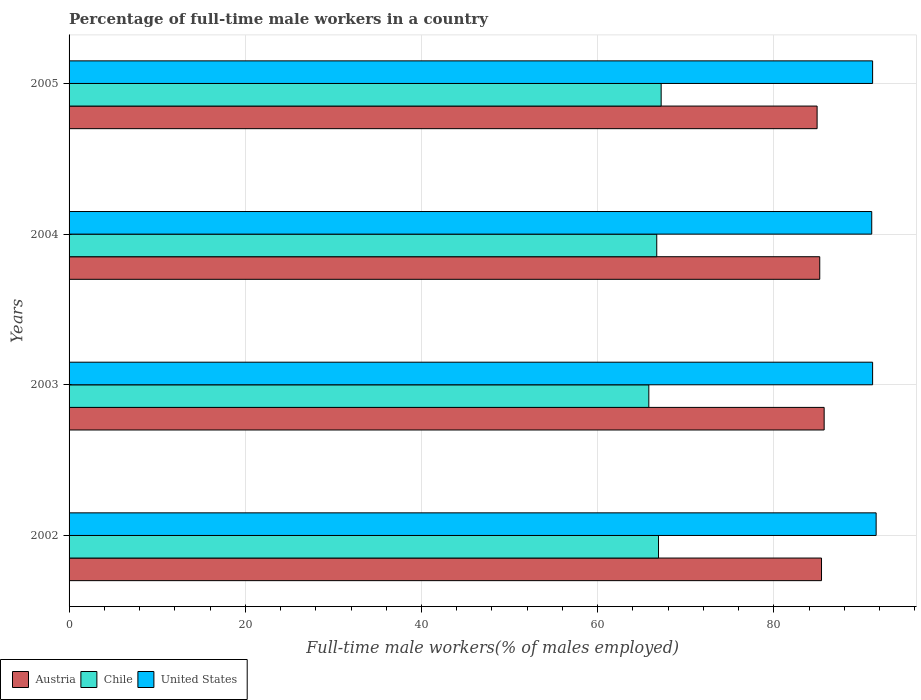How many different coloured bars are there?
Keep it short and to the point. 3. How many groups of bars are there?
Provide a short and direct response. 4. Are the number of bars per tick equal to the number of legend labels?
Give a very brief answer. Yes. How many bars are there on the 1st tick from the top?
Your response must be concise. 3. How many bars are there on the 3rd tick from the bottom?
Provide a short and direct response. 3. In how many cases, is the number of bars for a given year not equal to the number of legend labels?
Offer a terse response. 0. What is the percentage of full-time male workers in Austria in 2003?
Make the answer very short. 85.7. Across all years, what is the maximum percentage of full-time male workers in Austria?
Ensure brevity in your answer.  85.7. Across all years, what is the minimum percentage of full-time male workers in Chile?
Provide a succinct answer. 65.8. In which year was the percentage of full-time male workers in United States maximum?
Your answer should be very brief. 2002. What is the total percentage of full-time male workers in Austria in the graph?
Give a very brief answer. 341.2. What is the difference between the percentage of full-time male workers in Chile in 2002 and that in 2005?
Your response must be concise. -0.3. What is the difference between the percentage of full-time male workers in Austria in 2003 and the percentage of full-time male workers in Chile in 2002?
Offer a terse response. 18.8. What is the average percentage of full-time male workers in Chile per year?
Make the answer very short. 66.65. In the year 2002, what is the difference between the percentage of full-time male workers in United States and percentage of full-time male workers in Austria?
Ensure brevity in your answer.  6.2. What is the ratio of the percentage of full-time male workers in United States in 2004 to that in 2005?
Provide a succinct answer. 1. Is the percentage of full-time male workers in Austria in 2003 less than that in 2004?
Your response must be concise. No. Is the difference between the percentage of full-time male workers in United States in 2002 and 2004 greater than the difference between the percentage of full-time male workers in Austria in 2002 and 2004?
Give a very brief answer. Yes. What is the difference between the highest and the second highest percentage of full-time male workers in Chile?
Provide a succinct answer. 0.3. What is the difference between the highest and the lowest percentage of full-time male workers in Chile?
Give a very brief answer. 1.4. In how many years, is the percentage of full-time male workers in United States greater than the average percentage of full-time male workers in United States taken over all years?
Your answer should be very brief. 1. What does the 3rd bar from the top in 2005 represents?
Ensure brevity in your answer.  Austria. What does the 2nd bar from the bottom in 2003 represents?
Provide a succinct answer. Chile. Is it the case that in every year, the sum of the percentage of full-time male workers in United States and percentage of full-time male workers in Chile is greater than the percentage of full-time male workers in Austria?
Keep it short and to the point. Yes. How many bars are there?
Offer a very short reply. 12. Are the values on the major ticks of X-axis written in scientific E-notation?
Your response must be concise. No. Does the graph contain any zero values?
Offer a very short reply. No. Where does the legend appear in the graph?
Ensure brevity in your answer.  Bottom left. What is the title of the graph?
Provide a succinct answer. Percentage of full-time male workers in a country. What is the label or title of the X-axis?
Your answer should be compact. Full-time male workers(% of males employed). What is the label or title of the Y-axis?
Your answer should be compact. Years. What is the Full-time male workers(% of males employed) in Austria in 2002?
Ensure brevity in your answer.  85.4. What is the Full-time male workers(% of males employed) of Chile in 2002?
Provide a short and direct response. 66.9. What is the Full-time male workers(% of males employed) of United States in 2002?
Provide a succinct answer. 91.6. What is the Full-time male workers(% of males employed) in Austria in 2003?
Your response must be concise. 85.7. What is the Full-time male workers(% of males employed) in Chile in 2003?
Make the answer very short. 65.8. What is the Full-time male workers(% of males employed) in United States in 2003?
Provide a succinct answer. 91.2. What is the Full-time male workers(% of males employed) of Austria in 2004?
Give a very brief answer. 85.2. What is the Full-time male workers(% of males employed) of Chile in 2004?
Make the answer very short. 66.7. What is the Full-time male workers(% of males employed) of United States in 2004?
Ensure brevity in your answer.  91.1. What is the Full-time male workers(% of males employed) of Austria in 2005?
Your response must be concise. 84.9. What is the Full-time male workers(% of males employed) in Chile in 2005?
Give a very brief answer. 67.2. What is the Full-time male workers(% of males employed) of United States in 2005?
Provide a short and direct response. 91.2. Across all years, what is the maximum Full-time male workers(% of males employed) in Austria?
Make the answer very short. 85.7. Across all years, what is the maximum Full-time male workers(% of males employed) in Chile?
Ensure brevity in your answer.  67.2. Across all years, what is the maximum Full-time male workers(% of males employed) of United States?
Ensure brevity in your answer.  91.6. Across all years, what is the minimum Full-time male workers(% of males employed) of Austria?
Ensure brevity in your answer.  84.9. Across all years, what is the minimum Full-time male workers(% of males employed) of Chile?
Offer a very short reply. 65.8. Across all years, what is the minimum Full-time male workers(% of males employed) in United States?
Provide a succinct answer. 91.1. What is the total Full-time male workers(% of males employed) in Austria in the graph?
Your answer should be very brief. 341.2. What is the total Full-time male workers(% of males employed) of Chile in the graph?
Provide a succinct answer. 266.6. What is the total Full-time male workers(% of males employed) in United States in the graph?
Keep it short and to the point. 365.1. What is the difference between the Full-time male workers(% of males employed) of United States in 2002 and that in 2003?
Keep it short and to the point. 0.4. What is the difference between the Full-time male workers(% of males employed) in Austria in 2002 and that in 2004?
Provide a short and direct response. 0.2. What is the difference between the Full-time male workers(% of males employed) of Chile in 2002 and that in 2004?
Ensure brevity in your answer.  0.2. What is the difference between the Full-time male workers(% of males employed) in United States in 2002 and that in 2005?
Provide a short and direct response. 0.4. What is the difference between the Full-time male workers(% of males employed) in Austria in 2003 and that in 2004?
Offer a terse response. 0.5. What is the difference between the Full-time male workers(% of males employed) of United States in 2003 and that in 2004?
Your answer should be very brief. 0.1. What is the difference between the Full-time male workers(% of males employed) in Austria in 2003 and that in 2005?
Your response must be concise. 0.8. What is the difference between the Full-time male workers(% of males employed) in Austria in 2004 and that in 2005?
Give a very brief answer. 0.3. What is the difference between the Full-time male workers(% of males employed) in Chile in 2004 and that in 2005?
Offer a very short reply. -0.5. What is the difference between the Full-time male workers(% of males employed) in Austria in 2002 and the Full-time male workers(% of males employed) in Chile in 2003?
Provide a succinct answer. 19.6. What is the difference between the Full-time male workers(% of males employed) in Austria in 2002 and the Full-time male workers(% of males employed) in United States in 2003?
Provide a short and direct response. -5.8. What is the difference between the Full-time male workers(% of males employed) in Chile in 2002 and the Full-time male workers(% of males employed) in United States in 2003?
Make the answer very short. -24.3. What is the difference between the Full-time male workers(% of males employed) of Chile in 2002 and the Full-time male workers(% of males employed) of United States in 2004?
Your response must be concise. -24.2. What is the difference between the Full-time male workers(% of males employed) in Chile in 2002 and the Full-time male workers(% of males employed) in United States in 2005?
Give a very brief answer. -24.3. What is the difference between the Full-time male workers(% of males employed) in Chile in 2003 and the Full-time male workers(% of males employed) in United States in 2004?
Offer a terse response. -25.3. What is the difference between the Full-time male workers(% of males employed) in Austria in 2003 and the Full-time male workers(% of males employed) in Chile in 2005?
Give a very brief answer. 18.5. What is the difference between the Full-time male workers(% of males employed) of Austria in 2003 and the Full-time male workers(% of males employed) of United States in 2005?
Your answer should be compact. -5.5. What is the difference between the Full-time male workers(% of males employed) of Chile in 2003 and the Full-time male workers(% of males employed) of United States in 2005?
Your answer should be compact. -25.4. What is the difference between the Full-time male workers(% of males employed) in Austria in 2004 and the Full-time male workers(% of males employed) in Chile in 2005?
Keep it short and to the point. 18. What is the difference between the Full-time male workers(% of males employed) in Austria in 2004 and the Full-time male workers(% of males employed) in United States in 2005?
Give a very brief answer. -6. What is the difference between the Full-time male workers(% of males employed) in Chile in 2004 and the Full-time male workers(% of males employed) in United States in 2005?
Ensure brevity in your answer.  -24.5. What is the average Full-time male workers(% of males employed) in Austria per year?
Provide a succinct answer. 85.3. What is the average Full-time male workers(% of males employed) of Chile per year?
Ensure brevity in your answer.  66.65. What is the average Full-time male workers(% of males employed) in United States per year?
Give a very brief answer. 91.28. In the year 2002, what is the difference between the Full-time male workers(% of males employed) of Austria and Full-time male workers(% of males employed) of Chile?
Give a very brief answer. 18.5. In the year 2002, what is the difference between the Full-time male workers(% of males employed) of Chile and Full-time male workers(% of males employed) of United States?
Keep it short and to the point. -24.7. In the year 2003, what is the difference between the Full-time male workers(% of males employed) in Chile and Full-time male workers(% of males employed) in United States?
Provide a short and direct response. -25.4. In the year 2004, what is the difference between the Full-time male workers(% of males employed) of Austria and Full-time male workers(% of males employed) of United States?
Your answer should be very brief. -5.9. In the year 2004, what is the difference between the Full-time male workers(% of males employed) of Chile and Full-time male workers(% of males employed) of United States?
Give a very brief answer. -24.4. In the year 2005, what is the difference between the Full-time male workers(% of males employed) of Austria and Full-time male workers(% of males employed) of Chile?
Ensure brevity in your answer.  17.7. In the year 2005, what is the difference between the Full-time male workers(% of males employed) of Austria and Full-time male workers(% of males employed) of United States?
Ensure brevity in your answer.  -6.3. In the year 2005, what is the difference between the Full-time male workers(% of males employed) of Chile and Full-time male workers(% of males employed) of United States?
Keep it short and to the point. -24. What is the ratio of the Full-time male workers(% of males employed) in Chile in 2002 to that in 2003?
Provide a succinct answer. 1.02. What is the ratio of the Full-time male workers(% of males employed) in Austria in 2002 to that in 2004?
Make the answer very short. 1. What is the ratio of the Full-time male workers(% of males employed) of Chile in 2002 to that in 2004?
Provide a succinct answer. 1. What is the ratio of the Full-time male workers(% of males employed) of Austria in 2002 to that in 2005?
Make the answer very short. 1.01. What is the ratio of the Full-time male workers(% of males employed) of Austria in 2003 to that in 2004?
Your answer should be very brief. 1.01. What is the ratio of the Full-time male workers(% of males employed) of Chile in 2003 to that in 2004?
Provide a succinct answer. 0.99. What is the ratio of the Full-time male workers(% of males employed) in United States in 2003 to that in 2004?
Provide a short and direct response. 1. What is the ratio of the Full-time male workers(% of males employed) in Austria in 2003 to that in 2005?
Provide a succinct answer. 1.01. What is the ratio of the Full-time male workers(% of males employed) of Chile in 2003 to that in 2005?
Keep it short and to the point. 0.98. What is the ratio of the Full-time male workers(% of males employed) in United States in 2003 to that in 2005?
Your answer should be very brief. 1. What is the ratio of the Full-time male workers(% of males employed) in Chile in 2004 to that in 2005?
Your answer should be compact. 0.99. What is the ratio of the Full-time male workers(% of males employed) of United States in 2004 to that in 2005?
Give a very brief answer. 1. What is the difference between the highest and the second highest Full-time male workers(% of males employed) of Austria?
Make the answer very short. 0.3. What is the difference between the highest and the second highest Full-time male workers(% of males employed) of United States?
Ensure brevity in your answer.  0.4. What is the difference between the highest and the lowest Full-time male workers(% of males employed) in Austria?
Provide a short and direct response. 0.8. What is the difference between the highest and the lowest Full-time male workers(% of males employed) in Chile?
Your answer should be compact. 1.4. 